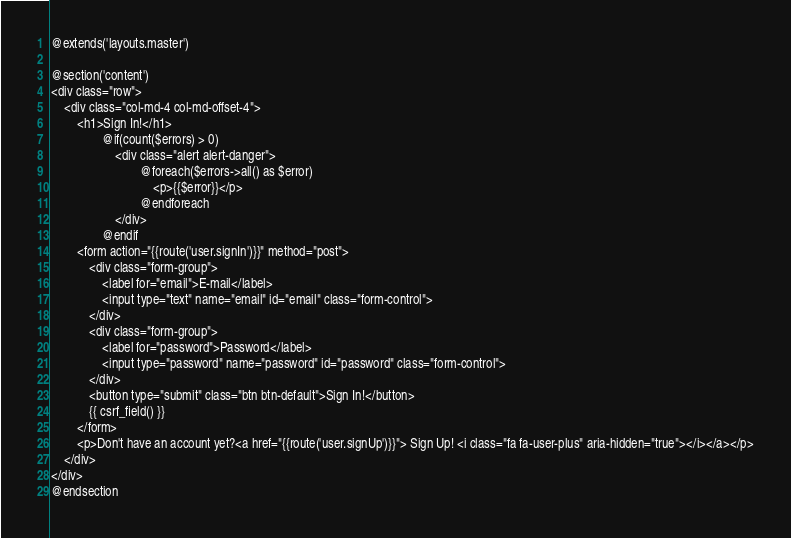<code> <loc_0><loc_0><loc_500><loc_500><_PHP_>@extends('layouts.master')

@section('content')
<div class="row">
	<div class="col-md-4 col-md-offset-4">
		<h1>Sign In!</h1>
				@if(count($errors) > 0)
					<div class="alert alert-danger">
							@foreach($errors->all() as $error)
								<p>{{$error}}</p>
							@endforeach
					</div>
				@endif
		<form action="{{route('user.signIn')}}" method="post">
			<div class="form-group">
				<label for="email">E-mail</label>
				<input type="text" name="email" id="email" class="form-control">				
			</div>
			<div class="form-group">
				<label for="password">Password</label>
				<input type="password" name="password" id="password" class="form-control">				
			</div>
			<button type="submit" class="btn btn-default">Sign In!</button>
			{{ csrf_field() }}
		</form>
		<p>Don't have an account yet?<a href="{{route('user.signUp')}}"> Sign Up! <i class="fa fa-user-plus" aria-hidden="true"></i></a></p>
	</div>
</div>
@endsection</code> 